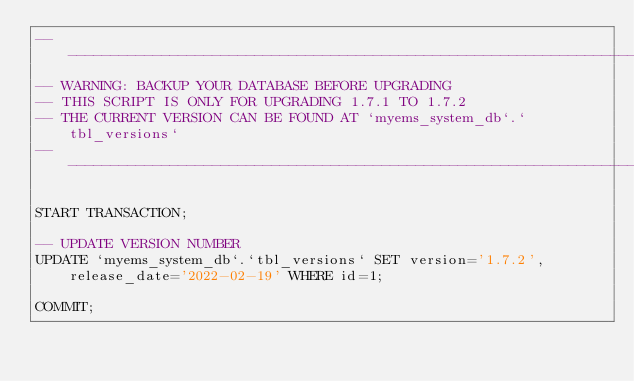Convert code to text. <code><loc_0><loc_0><loc_500><loc_500><_SQL_>-- ---------------------------------------------------------------------------------------------------------------------
-- WARNING: BACKUP YOUR DATABASE BEFORE UPGRADING
-- THIS SCRIPT IS ONLY FOR UPGRADING 1.7.1 TO 1.7.2
-- THE CURRENT VERSION CAN BE FOUND AT `myems_system_db`.`tbl_versions`
-- ---------------------------------------------------------------------------------------------------------------------

START TRANSACTION;

-- UPDATE VERSION NUMBER
UPDATE `myems_system_db`.`tbl_versions` SET version='1.7.2', release_date='2022-02-19' WHERE id=1;

COMMIT;</code> 